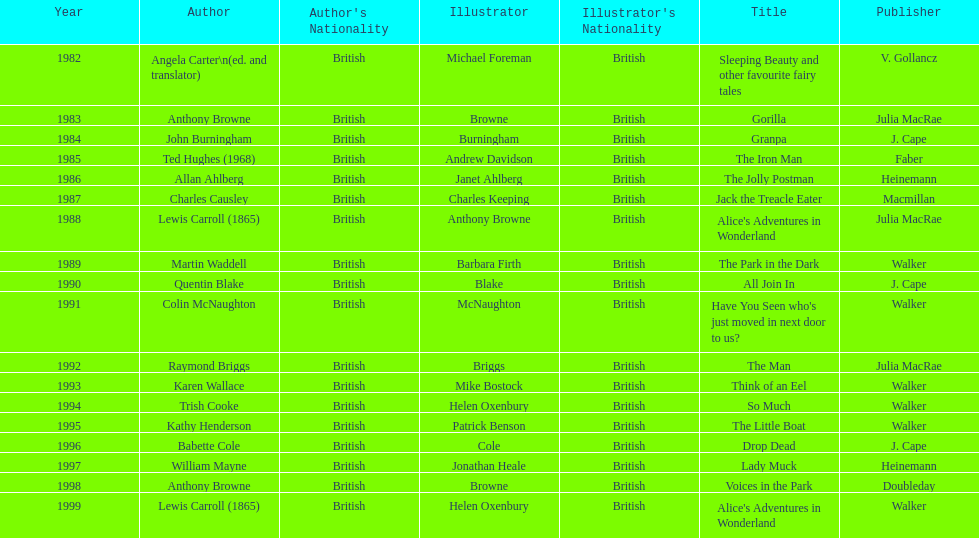What are the number of kurt maschler awards helen oxenbury has won? 2. 